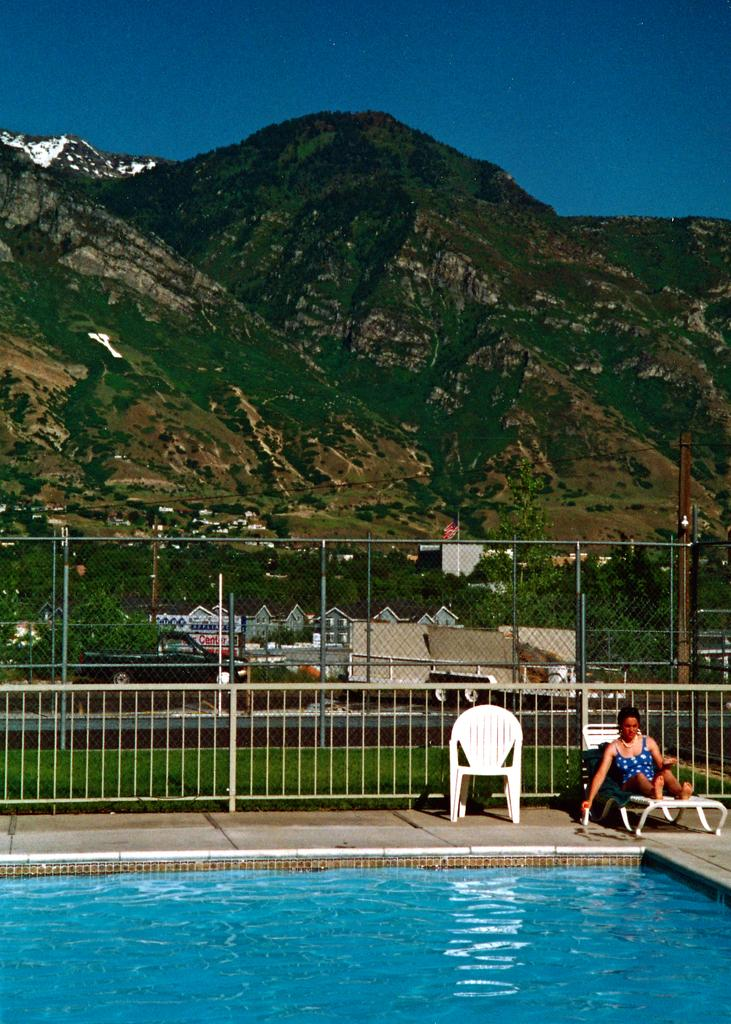Who is present in the image? There is a woman in the image. What is the woman doing in the image? The woman is sitting. What is in front of the woman? There is a swimming pool in front of the woman. What can be seen in the distance in the image? There are mountains in the background of the image. What type of substance is the woman using to enhance her neck in the image? There is no indication in the image that the woman is using any substance to enhance her neck. 